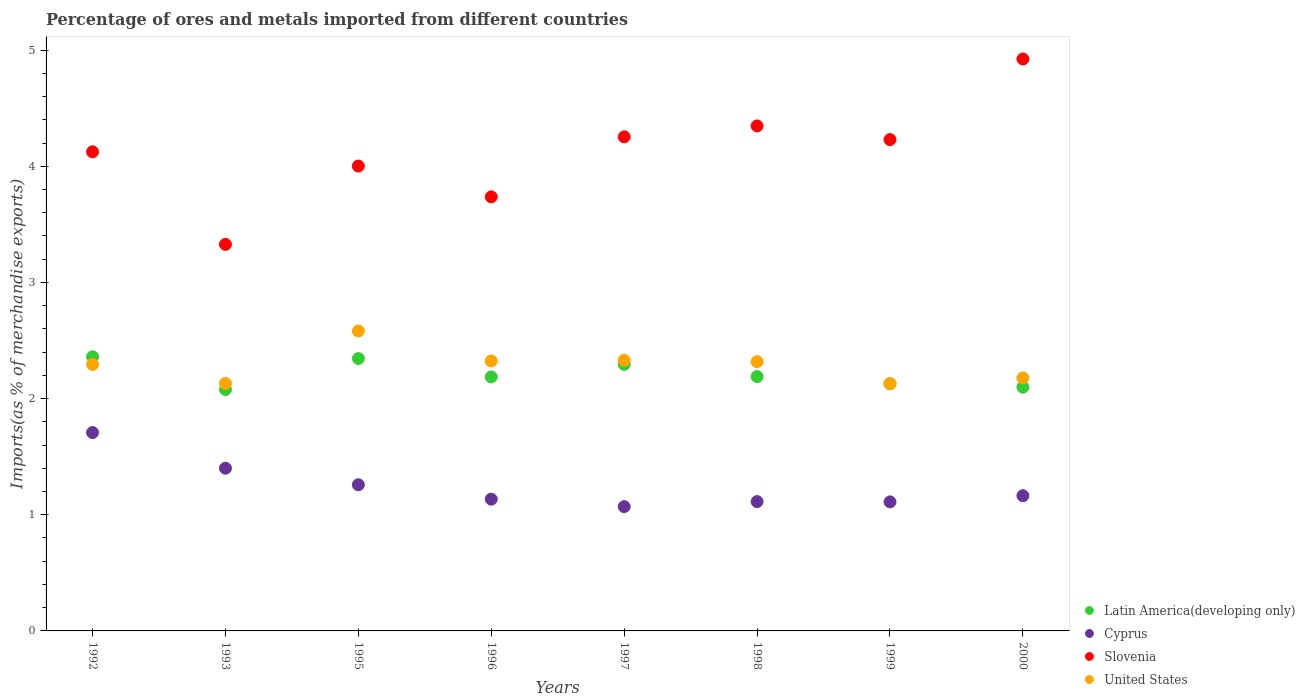How many different coloured dotlines are there?
Provide a short and direct response. 4. Is the number of dotlines equal to the number of legend labels?
Give a very brief answer. Yes. What is the percentage of imports to different countries in Slovenia in 1997?
Ensure brevity in your answer.  4.25. Across all years, what is the maximum percentage of imports to different countries in Latin America(developing only)?
Offer a terse response. 2.36. Across all years, what is the minimum percentage of imports to different countries in Slovenia?
Ensure brevity in your answer.  3.33. What is the total percentage of imports to different countries in United States in the graph?
Provide a succinct answer. 18.28. What is the difference between the percentage of imports to different countries in United States in 1992 and that in 1998?
Ensure brevity in your answer.  -0.02. What is the difference between the percentage of imports to different countries in United States in 2000 and the percentage of imports to different countries in Cyprus in 1996?
Your answer should be compact. 1.04. What is the average percentage of imports to different countries in United States per year?
Offer a terse response. 2.29. In the year 1996, what is the difference between the percentage of imports to different countries in Cyprus and percentage of imports to different countries in Latin America(developing only)?
Provide a succinct answer. -1.05. In how many years, is the percentage of imports to different countries in Latin America(developing only) greater than 1.2 %?
Give a very brief answer. 8. What is the ratio of the percentage of imports to different countries in United States in 1993 to that in 1995?
Ensure brevity in your answer.  0.83. Is the percentage of imports to different countries in Latin America(developing only) in 1996 less than that in 1997?
Provide a succinct answer. Yes. What is the difference between the highest and the second highest percentage of imports to different countries in Slovenia?
Offer a terse response. 0.58. What is the difference between the highest and the lowest percentage of imports to different countries in Latin America(developing only)?
Your answer should be compact. 0.28. In how many years, is the percentage of imports to different countries in Latin America(developing only) greater than the average percentage of imports to different countries in Latin America(developing only) taken over all years?
Offer a very short reply. 3. Does the percentage of imports to different countries in United States monotonically increase over the years?
Provide a succinct answer. No. Is the percentage of imports to different countries in Slovenia strictly less than the percentage of imports to different countries in United States over the years?
Make the answer very short. No. Does the graph contain grids?
Provide a short and direct response. No. Where does the legend appear in the graph?
Your answer should be compact. Bottom right. What is the title of the graph?
Make the answer very short. Percentage of ores and metals imported from different countries. What is the label or title of the X-axis?
Keep it short and to the point. Years. What is the label or title of the Y-axis?
Offer a very short reply. Imports(as % of merchandise exports). What is the Imports(as % of merchandise exports) in Latin America(developing only) in 1992?
Provide a succinct answer. 2.36. What is the Imports(as % of merchandise exports) of Cyprus in 1992?
Provide a succinct answer. 1.71. What is the Imports(as % of merchandise exports) in Slovenia in 1992?
Provide a succinct answer. 4.12. What is the Imports(as % of merchandise exports) in United States in 1992?
Give a very brief answer. 2.29. What is the Imports(as % of merchandise exports) in Latin America(developing only) in 1993?
Your answer should be compact. 2.08. What is the Imports(as % of merchandise exports) of Cyprus in 1993?
Provide a succinct answer. 1.4. What is the Imports(as % of merchandise exports) in Slovenia in 1993?
Provide a succinct answer. 3.33. What is the Imports(as % of merchandise exports) of United States in 1993?
Your answer should be very brief. 2.13. What is the Imports(as % of merchandise exports) of Latin America(developing only) in 1995?
Provide a short and direct response. 2.34. What is the Imports(as % of merchandise exports) of Cyprus in 1995?
Ensure brevity in your answer.  1.26. What is the Imports(as % of merchandise exports) of Slovenia in 1995?
Offer a very short reply. 4. What is the Imports(as % of merchandise exports) in United States in 1995?
Your response must be concise. 2.58. What is the Imports(as % of merchandise exports) of Latin America(developing only) in 1996?
Provide a succinct answer. 2.19. What is the Imports(as % of merchandise exports) of Cyprus in 1996?
Ensure brevity in your answer.  1.13. What is the Imports(as % of merchandise exports) of Slovenia in 1996?
Provide a short and direct response. 3.74. What is the Imports(as % of merchandise exports) in United States in 1996?
Offer a terse response. 2.32. What is the Imports(as % of merchandise exports) in Latin America(developing only) in 1997?
Provide a short and direct response. 2.29. What is the Imports(as % of merchandise exports) in Cyprus in 1997?
Your answer should be very brief. 1.07. What is the Imports(as % of merchandise exports) in Slovenia in 1997?
Your answer should be very brief. 4.25. What is the Imports(as % of merchandise exports) of United States in 1997?
Keep it short and to the point. 2.33. What is the Imports(as % of merchandise exports) of Latin America(developing only) in 1998?
Your response must be concise. 2.19. What is the Imports(as % of merchandise exports) of Cyprus in 1998?
Provide a succinct answer. 1.11. What is the Imports(as % of merchandise exports) in Slovenia in 1998?
Offer a very short reply. 4.35. What is the Imports(as % of merchandise exports) in United States in 1998?
Keep it short and to the point. 2.32. What is the Imports(as % of merchandise exports) of Latin America(developing only) in 1999?
Keep it short and to the point. 2.13. What is the Imports(as % of merchandise exports) of Cyprus in 1999?
Your answer should be compact. 1.11. What is the Imports(as % of merchandise exports) in Slovenia in 1999?
Your answer should be compact. 4.23. What is the Imports(as % of merchandise exports) in United States in 1999?
Provide a short and direct response. 2.13. What is the Imports(as % of merchandise exports) in Latin America(developing only) in 2000?
Your answer should be compact. 2.1. What is the Imports(as % of merchandise exports) of Cyprus in 2000?
Your answer should be very brief. 1.16. What is the Imports(as % of merchandise exports) in Slovenia in 2000?
Your answer should be very brief. 4.92. What is the Imports(as % of merchandise exports) of United States in 2000?
Your response must be concise. 2.18. Across all years, what is the maximum Imports(as % of merchandise exports) in Latin America(developing only)?
Offer a very short reply. 2.36. Across all years, what is the maximum Imports(as % of merchandise exports) of Cyprus?
Keep it short and to the point. 1.71. Across all years, what is the maximum Imports(as % of merchandise exports) of Slovenia?
Your answer should be compact. 4.92. Across all years, what is the maximum Imports(as % of merchandise exports) in United States?
Your answer should be very brief. 2.58. Across all years, what is the minimum Imports(as % of merchandise exports) in Latin America(developing only)?
Offer a very short reply. 2.08. Across all years, what is the minimum Imports(as % of merchandise exports) in Cyprus?
Your answer should be very brief. 1.07. Across all years, what is the minimum Imports(as % of merchandise exports) in Slovenia?
Provide a succinct answer. 3.33. Across all years, what is the minimum Imports(as % of merchandise exports) of United States?
Your answer should be very brief. 2.13. What is the total Imports(as % of merchandise exports) of Latin America(developing only) in the graph?
Make the answer very short. 17.68. What is the total Imports(as % of merchandise exports) of Cyprus in the graph?
Ensure brevity in your answer.  9.96. What is the total Imports(as % of merchandise exports) of Slovenia in the graph?
Keep it short and to the point. 32.94. What is the total Imports(as % of merchandise exports) of United States in the graph?
Provide a succinct answer. 18.28. What is the difference between the Imports(as % of merchandise exports) of Latin America(developing only) in 1992 and that in 1993?
Offer a very short reply. 0.28. What is the difference between the Imports(as % of merchandise exports) of Cyprus in 1992 and that in 1993?
Your answer should be compact. 0.31. What is the difference between the Imports(as % of merchandise exports) in Slovenia in 1992 and that in 1993?
Provide a short and direct response. 0.8. What is the difference between the Imports(as % of merchandise exports) of United States in 1992 and that in 1993?
Make the answer very short. 0.16. What is the difference between the Imports(as % of merchandise exports) in Latin America(developing only) in 1992 and that in 1995?
Ensure brevity in your answer.  0.02. What is the difference between the Imports(as % of merchandise exports) of Cyprus in 1992 and that in 1995?
Make the answer very short. 0.45. What is the difference between the Imports(as % of merchandise exports) of Slovenia in 1992 and that in 1995?
Offer a terse response. 0.12. What is the difference between the Imports(as % of merchandise exports) in United States in 1992 and that in 1995?
Offer a terse response. -0.29. What is the difference between the Imports(as % of merchandise exports) in Latin America(developing only) in 1992 and that in 1996?
Make the answer very short. 0.17. What is the difference between the Imports(as % of merchandise exports) in Cyprus in 1992 and that in 1996?
Your response must be concise. 0.57. What is the difference between the Imports(as % of merchandise exports) of Slovenia in 1992 and that in 1996?
Make the answer very short. 0.39. What is the difference between the Imports(as % of merchandise exports) of United States in 1992 and that in 1996?
Your answer should be very brief. -0.03. What is the difference between the Imports(as % of merchandise exports) of Latin America(developing only) in 1992 and that in 1997?
Keep it short and to the point. 0.07. What is the difference between the Imports(as % of merchandise exports) in Cyprus in 1992 and that in 1997?
Make the answer very short. 0.64. What is the difference between the Imports(as % of merchandise exports) of Slovenia in 1992 and that in 1997?
Provide a short and direct response. -0.13. What is the difference between the Imports(as % of merchandise exports) in United States in 1992 and that in 1997?
Your answer should be compact. -0.04. What is the difference between the Imports(as % of merchandise exports) in Latin America(developing only) in 1992 and that in 1998?
Ensure brevity in your answer.  0.17. What is the difference between the Imports(as % of merchandise exports) of Cyprus in 1992 and that in 1998?
Your response must be concise. 0.59. What is the difference between the Imports(as % of merchandise exports) of Slovenia in 1992 and that in 1998?
Provide a succinct answer. -0.22. What is the difference between the Imports(as % of merchandise exports) in United States in 1992 and that in 1998?
Ensure brevity in your answer.  -0.02. What is the difference between the Imports(as % of merchandise exports) in Latin America(developing only) in 1992 and that in 1999?
Offer a terse response. 0.23. What is the difference between the Imports(as % of merchandise exports) of Cyprus in 1992 and that in 1999?
Provide a short and direct response. 0.6. What is the difference between the Imports(as % of merchandise exports) in Slovenia in 1992 and that in 1999?
Your response must be concise. -0.11. What is the difference between the Imports(as % of merchandise exports) in United States in 1992 and that in 1999?
Keep it short and to the point. 0.16. What is the difference between the Imports(as % of merchandise exports) of Latin America(developing only) in 1992 and that in 2000?
Provide a succinct answer. 0.26. What is the difference between the Imports(as % of merchandise exports) in Cyprus in 1992 and that in 2000?
Your answer should be compact. 0.54. What is the difference between the Imports(as % of merchandise exports) in Slovenia in 1992 and that in 2000?
Ensure brevity in your answer.  -0.8. What is the difference between the Imports(as % of merchandise exports) in United States in 1992 and that in 2000?
Offer a terse response. 0.12. What is the difference between the Imports(as % of merchandise exports) in Latin America(developing only) in 1993 and that in 1995?
Make the answer very short. -0.27. What is the difference between the Imports(as % of merchandise exports) of Cyprus in 1993 and that in 1995?
Your answer should be very brief. 0.14. What is the difference between the Imports(as % of merchandise exports) in Slovenia in 1993 and that in 1995?
Offer a terse response. -0.67. What is the difference between the Imports(as % of merchandise exports) of United States in 1993 and that in 1995?
Your answer should be very brief. -0.45. What is the difference between the Imports(as % of merchandise exports) of Latin America(developing only) in 1993 and that in 1996?
Keep it short and to the point. -0.11. What is the difference between the Imports(as % of merchandise exports) in Cyprus in 1993 and that in 1996?
Your response must be concise. 0.27. What is the difference between the Imports(as % of merchandise exports) in Slovenia in 1993 and that in 1996?
Keep it short and to the point. -0.41. What is the difference between the Imports(as % of merchandise exports) in United States in 1993 and that in 1996?
Offer a terse response. -0.19. What is the difference between the Imports(as % of merchandise exports) of Latin America(developing only) in 1993 and that in 1997?
Offer a very short reply. -0.22. What is the difference between the Imports(as % of merchandise exports) of Cyprus in 1993 and that in 1997?
Your answer should be compact. 0.33. What is the difference between the Imports(as % of merchandise exports) in Slovenia in 1993 and that in 1997?
Your response must be concise. -0.93. What is the difference between the Imports(as % of merchandise exports) of United States in 1993 and that in 1997?
Your answer should be compact. -0.2. What is the difference between the Imports(as % of merchandise exports) in Latin America(developing only) in 1993 and that in 1998?
Offer a terse response. -0.11. What is the difference between the Imports(as % of merchandise exports) of Cyprus in 1993 and that in 1998?
Keep it short and to the point. 0.29. What is the difference between the Imports(as % of merchandise exports) in Slovenia in 1993 and that in 1998?
Offer a very short reply. -1.02. What is the difference between the Imports(as % of merchandise exports) of United States in 1993 and that in 1998?
Offer a very short reply. -0.19. What is the difference between the Imports(as % of merchandise exports) of Latin America(developing only) in 1993 and that in 1999?
Offer a terse response. -0.05. What is the difference between the Imports(as % of merchandise exports) of Cyprus in 1993 and that in 1999?
Your answer should be compact. 0.29. What is the difference between the Imports(as % of merchandise exports) in Slovenia in 1993 and that in 1999?
Provide a short and direct response. -0.9. What is the difference between the Imports(as % of merchandise exports) of United States in 1993 and that in 1999?
Provide a short and direct response. 0. What is the difference between the Imports(as % of merchandise exports) of Latin America(developing only) in 1993 and that in 2000?
Make the answer very short. -0.02. What is the difference between the Imports(as % of merchandise exports) in Cyprus in 1993 and that in 2000?
Give a very brief answer. 0.24. What is the difference between the Imports(as % of merchandise exports) of Slovenia in 1993 and that in 2000?
Keep it short and to the point. -1.6. What is the difference between the Imports(as % of merchandise exports) of United States in 1993 and that in 2000?
Keep it short and to the point. -0.05. What is the difference between the Imports(as % of merchandise exports) in Latin America(developing only) in 1995 and that in 1996?
Provide a succinct answer. 0.16. What is the difference between the Imports(as % of merchandise exports) in Cyprus in 1995 and that in 1996?
Your response must be concise. 0.12. What is the difference between the Imports(as % of merchandise exports) in Slovenia in 1995 and that in 1996?
Provide a succinct answer. 0.27. What is the difference between the Imports(as % of merchandise exports) of United States in 1995 and that in 1996?
Make the answer very short. 0.26. What is the difference between the Imports(as % of merchandise exports) of Latin America(developing only) in 1995 and that in 1997?
Give a very brief answer. 0.05. What is the difference between the Imports(as % of merchandise exports) in Cyprus in 1995 and that in 1997?
Make the answer very short. 0.19. What is the difference between the Imports(as % of merchandise exports) of Slovenia in 1995 and that in 1997?
Your response must be concise. -0.25. What is the difference between the Imports(as % of merchandise exports) in United States in 1995 and that in 1997?
Offer a terse response. 0.25. What is the difference between the Imports(as % of merchandise exports) of Latin America(developing only) in 1995 and that in 1998?
Give a very brief answer. 0.16. What is the difference between the Imports(as % of merchandise exports) of Cyprus in 1995 and that in 1998?
Your response must be concise. 0.14. What is the difference between the Imports(as % of merchandise exports) of Slovenia in 1995 and that in 1998?
Provide a succinct answer. -0.35. What is the difference between the Imports(as % of merchandise exports) in United States in 1995 and that in 1998?
Give a very brief answer. 0.26. What is the difference between the Imports(as % of merchandise exports) of Latin America(developing only) in 1995 and that in 1999?
Offer a very short reply. 0.22. What is the difference between the Imports(as % of merchandise exports) of Cyprus in 1995 and that in 1999?
Ensure brevity in your answer.  0.15. What is the difference between the Imports(as % of merchandise exports) of Slovenia in 1995 and that in 1999?
Your answer should be very brief. -0.23. What is the difference between the Imports(as % of merchandise exports) of United States in 1995 and that in 1999?
Your response must be concise. 0.45. What is the difference between the Imports(as % of merchandise exports) of Latin America(developing only) in 1995 and that in 2000?
Offer a very short reply. 0.25. What is the difference between the Imports(as % of merchandise exports) of Cyprus in 1995 and that in 2000?
Your answer should be very brief. 0.09. What is the difference between the Imports(as % of merchandise exports) in Slovenia in 1995 and that in 2000?
Ensure brevity in your answer.  -0.92. What is the difference between the Imports(as % of merchandise exports) of United States in 1995 and that in 2000?
Offer a very short reply. 0.4. What is the difference between the Imports(as % of merchandise exports) of Latin America(developing only) in 1996 and that in 1997?
Your answer should be compact. -0.11. What is the difference between the Imports(as % of merchandise exports) in Cyprus in 1996 and that in 1997?
Your answer should be compact. 0.06. What is the difference between the Imports(as % of merchandise exports) of Slovenia in 1996 and that in 1997?
Your response must be concise. -0.52. What is the difference between the Imports(as % of merchandise exports) of United States in 1996 and that in 1997?
Your response must be concise. -0.01. What is the difference between the Imports(as % of merchandise exports) in Latin America(developing only) in 1996 and that in 1998?
Give a very brief answer. -0. What is the difference between the Imports(as % of merchandise exports) in Cyprus in 1996 and that in 1998?
Keep it short and to the point. 0.02. What is the difference between the Imports(as % of merchandise exports) in Slovenia in 1996 and that in 1998?
Offer a terse response. -0.61. What is the difference between the Imports(as % of merchandise exports) in United States in 1996 and that in 1998?
Offer a very short reply. 0.01. What is the difference between the Imports(as % of merchandise exports) of Latin America(developing only) in 1996 and that in 1999?
Ensure brevity in your answer.  0.06. What is the difference between the Imports(as % of merchandise exports) in Cyprus in 1996 and that in 1999?
Make the answer very short. 0.02. What is the difference between the Imports(as % of merchandise exports) in Slovenia in 1996 and that in 1999?
Provide a succinct answer. -0.49. What is the difference between the Imports(as % of merchandise exports) of United States in 1996 and that in 1999?
Provide a short and direct response. 0.19. What is the difference between the Imports(as % of merchandise exports) in Latin America(developing only) in 1996 and that in 2000?
Give a very brief answer. 0.09. What is the difference between the Imports(as % of merchandise exports) in Cyprus in 1996 and that in 2000?
Provide a short and direct response. -0.03. What is the difference between the Imports(as % of merchandise exports) in Slovenia in 1996 and that in 2000?
Give a very brief answer. -1.19. What is the difference between the Imports(as % of merchandise exports) in United States in 1996 and that in 2000?
Your answer should be very brief. 0.15. What is the difference between the Imports(as % of merchandise exports) of Latin America(developing only) in 1997 and that in 1998?
Keep it short and to the point. 0.1. What is the difference between the Imports(as % of merchandise exports) of Cyprus in 1997 and that in 1998?
Your answer should be very brief. -0.04. What is the difference between the Imports(as % of merchandise exports) of Slovenia in 1997 and that in 1998?
Provide a short and direct response. -0.09. What is the difference between the Imports(as % of merchandise exports) in United States in 1997 and that in 1998?
Keep it short and to the point. 0.01. What is the difference between the Imports(as % of merchandise exports) in Latin America(developing only) in 1997 and that in 1999?
Your answer should be very brief. 0.17. What is the difference between the Imports(as % of merchandise exports) in Cyprus in 1997 and that in 1999?
Provide a short and direct response. -0.04. What is the difference between the Imports(as % of merchandise exports) of Slovenia in 1997 and that in 1999?
Keep it short and to the point. 0.02. What is the difference between the Imports(as % of merchandise exports) of United States in 1997 and that in 1999?
Provide a short and direct response. 0.2. What is the difference between the Imports(as % of merchandise exports) in Latin America(developing only) in 1997 and that in 2000?
Your answer should be very brief. 0.2. What is the difference between the Imports(as % of merchandise exports) in Cyprus in 1997 and that in 2000?
Make the answer very short. -0.09. What is the difference between the Imports(as % of merchandise exports) in Slovenia in 1997 and that in 2000?
Your answer should be compact. -0.67. What is the difference between the Imports(as % of merchandise exports) of United States in 1997 and that in 2000?
Your answer should be very brief. 0.15. What is the difference between the Imports(as % of merchandise exports) in Latin America(developing only) in 1998 and that in 1999?
Make the answer very short. 0.06. What is the difference between the Imports(as % of merchandise exports) in Cyprus in 1998 and that in 1999?
Provide a succinct answer. 0. What is the difference between the Imports(as % of merchandise exports) of Slovenia in 1998 and that in 1999?
Your response must be concise. 0.12. What is the difference between the Imports(as % of merchandise exports) of United States in 1998 and that in 1999?
Your response must be concise. 0.19. What is the difference between the Imports(as % of merchandise exports) in Latin America(developing only) in 1998 and that in 2000?
Offer a very short reply. 0.09. What is the difference between the Imports(as % of merchandise exports) in Cyprus in 1998 and that in 2000?
Your answer should be very brief. -0.05. What is the difference between the Imports(as % of merchandise exports) in Slovenia in 1998 and that in 2000?
Your response must be concise. -0.58. What is the difference between the Imports(as % of merchandise exports) of United States in 1998 and that in 2000?
Provide a short and direct response. 0.14. What is the difference between the Imports(as % of merchandise exports) of Latin America(developing only) in 1999 and that in 2000?
Give a very brief answer. 0.03. What is the difference between the Imports(as % of merchandise exports) in Cyprus in 1999 and that in 2000?
Make the answer very short. -0.05. What is the difference between the Imports(as % of merchandise exports) in Slovenia in 1999 and that in 2000?
Make the answer very short. -0.69. What is the difference between the Imports(as % of merchandise exports) of United States in 1999 and that in 2000?
Your answer should be very brief. -0.05. What is the difference between the Imports(as % of merchandise exports) in Latin America(developing only) in 1992 and the Imports(as % of merchandise exports) in Cyprus in 1993?
Provide a succinct answer. 0.96. What is the difference between the Imports(as % of merchandise exports) of Latin America(developing only) in 1992 and the Imports(as % of merchandise exports) of Slovenia in 1993?
Your response must be concise. -0.97. What is the difference between the Imports(as % of merchandise exports) in Latin America(developing only) in 1992 and the Imports(as % of merchandise exports) in United States in 1993?
Your response must be concise. 0.23. What is the difference between the Imports(as % of merchandise exports) in Cyprus in 1992 and the Imports(as % of merchandise exports) in Slovenia in 1993?
Offer a terse response. -1.62. What is the difference between the Imports(as % of merchandise exports) of Cyprus in 1992 and the Imports(as % of merchandise exports) of United States in 1993?
Your answer should be very brief. -0.42. What is the difference between the Imports(as % of merchandise exports) in Slovenia in 1992 and the Imports(as % of merchandise exports) in United States in 1993?
Your response must be concise. 1.99. What is the difference between the Imports(as % of merchandise exports) in Latin America(developing only) in 1992 and the Imports(as % of merchandise exports) in Cyprus in 1995?
Offer a very short reply. 1.1. What is the difference between the Imports(as % of merchandise exports) of Latin America(developing only) in 1992 and the Imports(as % of merchandise exports) of Slovenia in 1995?
Ensure brevity in your answer.  -1.64. What is the difference between the Imports(as % of merchandise exports) in Latin America(developing only) in 1992 and the Imports(as % of merchandise exports) in United States in 1995?
Keep it short and to the point. -0.22. What is the difference between the Imports(as % of merchandise exports) in Cyprus in 1992 and the Imports(as % of merchandise exports) in Slovenia in 1995?
Provide a short and direct response. -2.29. What is the difference between the Imports(as % of merchandise exports) in Cyprus in 1992 and the Imports(as % of merchandise exports) in United States in 1995?
Your answer should be very brief. -0.87. What is the difference between the Imports(as % of merchandise exports) of Slovenia in 1992 and the Imports(as % of merchandise exports) of United States in 1995?
Keep it short and to the point. 1.54. What is the difference between the Imports(as % of merchandise exports) of Latin America(developing only) in 1992 and the Imports(as % of merchandise exports) of Cyprus in 1996?
Offer a very short reply. 1.23. What is the difference between the Imports(as % of merchandise exports) of Latin America(developing only) in 1992 and the Imports(as % of merchandise exports) of Slovenia in 1996?
Your answer should be compact. -1.38. What is the difference between the Imports(as % of merchandise exports) of Latin America(developing only) in 1992 and the Imports(as % of merchandise exports) of United States in 1996?
Provide a short and direct response. 0.04. What is the difference between the Imports(as % of merchandise exports) of Cyprus in 1992 and the Imports(as % of merchandise exports) of Slovenia in 1996?
Your answer should be compact. -2.03. What is the difference between the Imports(as % of merchandise exports) in Cyprus in 1992 and the Imports(as % of merchandise exports) in United States in 1996?
Your response must be concise. -0.62. What is the difference between the Imports(as % of merchandise exports) of Slovenia in 1992 and the Imports(as % of merchandise exports) of United States in 1996?
Your answer should be compact. 1.8. What is the difference between the Imports(as % of merchandise exports) in Latin America(developing only) in 1992 and the Imports(as % of merchandise exports) in Cyprus in 1997?
Offer a very short reply. 1.29. What is the difference between the Imports(as % of merchandise exports) in Latin America(developing only) in 1992 and the Imports(as % of merchandise exports) in Slovenia in 1997?
Provide a succinct answer. -1.89. What is the difference between the Imports(as % of merchandise exports) in Latin America(developing only) in 1992 and the Imports(as % of merchandise exports) in United States in 1997?
Keep it short and to the point. 0.03. What is the difference between the Imports(as % of merchandise exports) of Cyprus in 1992 and the Imports(as % of merchandise exports) of Slovenia in 1997?
Your answer should be very brief. -2.55. What is the difference between the Imports(as % of merchandise exports) of Cyprus in 1992 and the Imports(as % of merchandise exports) of United States in 1997?
Offer a terse response. -0.62. What is the difference between the Imports(as % of merchandise exports) in Slovenia in 1992 and the Imports(as % of merchandise exports) in United States in 1997?
Provide a succinct answer. 1.79. What is the difference between the Imports(as % of merchandise exports) in Latin America(developing only) in 1992 and the Imports(as % of merchandise exports) in Cyprus in 1998?
Ensure brevity in your answer.  1.25. What is the difference between the Imports(as % of merchandise exports) in Latin America(developing only) in 1992 and the Imports(as % of merchandise exports) in Slovenia in 1998?
Offer a terse response. -1.99. What is the difference between the Imports(as % of merchandise exports) of Latin America(developing only) in 1992 and the Imports(as % of merchandise exports) of United States in 1998?
Your response must be concise. 0.04. What is the difference between the Imports(as % of merchandise exports) of Cyprus in 1992 and the Imports(as % of merchandise exports) of Slovenia in 1998?
Ensure brevity in your answer.  -2.64. What is the difference between the Imports(as % of merchandise exports) in Cyprus in 1992 and the Imports(as % of merchandise exports) in United States in 1998?
Offer a terse response. -0.61. What is the difference between the Imports(as % of merchandise exports) of Slovenia in 1992 and the Imports(as % of merchandise exports) of United States in 1998?
Offer a very short reply. 1.81. What is the difference between the Imports(as % of merchandise exports) of Latin America(developing only) in 1992 and the Imports(as % of merchandise exports) of Cyprus in 1999?
Offer a very short reply. 1.25. What is the difference between the Imports(as % of merchandise exports) of Latin America(developing only) in 1992 and the Imports(as % of merchandise exports) of Slovenia in 1999?
Give a very brief answer. -1.87. What is the difference between the Imports(as % of merchandise exports) in Latin America(developing only) in 1992 and the Imports(as % of merchandise exports) in United States in 1999?
Keep it short and to the point. 0.23. What is the difference between the Imports(as % of merchandise exports) of Cyprus in 1992 and the Imports(as % of merchandise exports) of Slovenia in 1999?
Provide a short and direct response. -2.52. What is the difference between the Imports(as % of merchandise exports) in Cyprus in 1992 and the Imports(as % of merchandise exports) in United States in 1999?
Ensure brevity in your answer.  -0.42. What is the difference between the Imports(as % of merchandise exports) in Slovenia in 1992 and the Imports(as % of merchandise exports) in United States in 1999?
Offer a very short reply. 2. What is the difference between the Imports(as % of merchandise exports) of Latin America(developing only) in 1992 and the Imports(as % of merchandise exports) of Cyprus in 2000?
Your answer should be compact. 1.2. What is the difference between the Imports(as % of merchandise exports) of Latin America(developing only) in 1992 and the Imports(as % of merchandise exports) of Slovenia in 2000?
Your response must be concise. -2.56. What is the difference between the Imports(as % of merchandise exports) in Latin America(developing only) in 1992 and the Imports(as % of merchandise exports) in United States in 2000?
Provide a short and direct response. 0.18. What is the difference between the Imports(as % of merchandise exports) of Cyprus in 1992 and the Imports(as % of merchandise exports) of Slovenia in 2000?
Make the answer very short. -3.22. What is the difference between the Imports(as % of merchandise exports) of Cyprus in 1992 and the Imports(as % of merchandise exports) of United States in 2000?
Offer a terse response. -0.47. What is the difference between the Imports(as % of merchandise exports) in Slovenia in 1992 and the Imports(as % of merchandise exports) in United States in 2000?
Provide a short and direct response. 1.95. What is the difference between the Imports(as % of merchandise exports) of Latin America(developing only) in 1993 and the Imports(as % of merchandise exports) of Cyprus in 1995?
Keep it short and to the point. 0.82. What is the difference between the Imports(as % of merchandise exports) of Latin America(developing only) in 1993 and the Imports(as % of merchandise exports) of Slovenia in 1995?
Keep it short and to the point. -1.92. What is the difference between the Imports(as % of merchandise exports) in Latin America(developing only) in 1993 and the Imports(as % of merchandise exports) in United States in 1995?
Make the answer very short. -0.5. What is the difference between the Imports(as % of merchandise exports) of Cyprus in 1993 and the Imports(as % of merchandise exports) of Slovenia in 1995?
Your answer should be very brief. -2.6. What is the difference between the Imports(as % of merchandise exports) in Cyprus in 1993 and the Imports(as % of merchandise exports) in United States in 1995?
Make the answer very short. -1.18. What is the difference between the Imports(as % of merchandise exports) of Slovenia in 1993 and the Imports(as % of merchandise exports) of United States in 1995?
Your response must be concise. 0.75. What is the difference between the Imports(as % of merchandise exports) in Latin America(developing only) in 1993 and the Imports(as % of merchandise exports) in Cyprus in 1996?
Make the answer very short. 0.94. What is the difference between the Imports(as % of merchandise exports) in Latin America(developing only) in 1993 and the Imports(as % of merchandise exports) in Slovenia in 1996?
Make the answer very short. -1.66. What is the difference between the Imports(as % of merchandise exports) of Latin America(developing only) in 1993 and the Imports(as % of merchandise exports) of United States in 1996?
Keep it short and to the point. -0.25. What is the difference between the Imports(as % of merchandise exports) of Cyprus in 1993 and the Imports(as % of merchandise exports) of Slovenia in 1996?
Offer a very short reply. -2.34. What is the difference between the Imports(as % of merchandise exports) in Cyprus in 1993 and the Imports(as % of merchandise exports) in United States in 1996?
Offer a very short reply. -0.92. What is the difference between the Imports(as % of merchandise exports) of Latin America(developing only) in 1993 and the Imports(as % of merchandise exports) of Cyprus in 1997?
Offer a very short reply. 1.01. What is the difference between the Imports(as % of merchandise exports) in Latin America(developing only) in 1993 and the Imports(as % of merchandise exports) in Slovenia in 1997?
Ensure brevity in your answer.  -2.18. What is the difference between the Imports(as % of merchandise exports) in Latin America(developing only) in 1993 and the Imports(as % of merchandise exports) in United States in 1997?
Provide a short and direct response. -0.25. What is the difference between the Imports(as % of merchandise exports) of Cyprus in 1993 and the Imports(as % of merchandise exports) of Slovenia in 1997?
Offer a very short reply. -2.85. What is the difference between the Imports(as % of merchandise exports) of Cyprus in 1993 and the Imports(as % of merchandise exports) of United States in 1997?
Ensure brevity in your answer.  -0.93. What is the difference between the Imports(as % of merchandise exports) in Slovenia in 1993 and the Imports(as % of merchandise exports) in United States in 1997?
Ensure brevity in your answer.  1. What is the difference between the Imports(as % of merchandise exports) in Latin America(developing only) in 1993 and the Imports(as % of merchandise exports) in Cyprus in 1998?
Your answer should be compact. 0.96. What is the difference between the Imports(as % of merchandise exports) in Latin America(developing only) in 1993 and the Imports(as % of merchandise exports) in Slovenia in 1998?
Keep it short and to the point. -2.27. What is the difference between the Imports(as % of merchandise exports) of Latin America(developing only) in 1993 and the Imports(as % of merchandise exports) of United States in 1998?
Ensure brevity in your answer.  -0.24. What is the difference between the Imports(as % of merchandise exports) in Cyprus in 1993 and the Imports(as % of merchandise exports) in Slovenia in 1998?
Offer a terse response. -2.95. What is the difference between the Imports(as % of merchandise exports) of Cyprus in 1993 and the Imports(as % of merchandise exports) of United States in 1998?
Offer a terse response. -0.92. What is the difference between the Imports(as % of merchandise exports) in Slovenia in 1993 and the Imports(as % of merchandise exports) in United States in 1998?
Provide a succinct answer. 1.01. What is the difference between the Imports(as % of merchandise exports) of Latin America(developing only) in 1993 and the Imports(as % of merchandise exports) of Cyprus in 1999?
Provide a short and direct response. 0.97. What is the difference between the Imports(as % of merchandise exports) of Latin America(developing only) in 1993 and the Imports(as % of merchandise exports) of Slovenia in 1999?
Ensure brevity in your answer.  -2.15. What is the difference between the Imports(as % of merchandise exports) in Latin America(developing only) in 1993 and the Imports(as % of merchandise exports) in United States in 1999?
Make the answer very short. -0.05. What is the difference between the Imports(as % of merchandise exports) in Cyprus in 1993 and the Imports(as % of merchandise exports) in Slovenia in 1999?
Offer a very short reply. -2.83. What is the difference between the Imports(as % of merchandise exports) in Cyprus in 1993 and the Imports(as % of merchandise exports) in United States in 1999?
Offer a terse response. -0.73. What is the difference between the Imports(as % of merchandise exports) in Slovenia in 1993 and the Imports(as % of merchandise exports) in United States in 1999?
Offer a terse response. 1.2. What is the difference between the Imports(as % of merchandise exports) in Latin America(developing only) in 1993 and the Imports(as % of merchandise exports) in Cyprus in 2000?
Provide a short and direct response. 0.91. What is the difference between the Imports(as % of merchandise exports) of Latin America(developing only) in 1993 and the Imports(as % of merchandise exports) of Slovenia in 2000?
Your answer should be compact. -2.85. What is the difference between the Imports(as % of merchandise exports) in Latin America(developing only) in 1993 and the Imports(as % of merchandise exports) in United States in 2000?
Provide a short and direct response. -0.1. What is the difference between the Imports(as % of merchandise exports) of Cyprus in 1993 and the Imports(as % of merchandise exports) of Slovenia in 2000?
Offer a very short reply. -3.52. What is the difference between the Imports(as % of merchandise exports) of Cyprus in 1993 and the Imports(as % of merchandise exports) of United States in 2000?
Offer a terse response. -0.78. What is the difference between the Imports(as % of merchandise exports) of Slovenia in 1993 and the Imports(as % of merchandise exports) of United States in 2000?
Make the answer very short. 1.15. What is the difference between the Imports(as % of merchandise exports) in Latin America(developing only) in 1995 and the Imports(as % of merchandise exports) in Cyprus in 1996?
Offer a very short reply. 1.21. What is the difference between the Imports(as % of merchandise exports) of Latin America(developing only) in 1995 and the Imports(as % of merchandise exports) of Slovenia in 1996?
Make the answer very short. -1.39. What is the difference between the Imports(as % of merchandise exports) of Latin America(developing only) in 1995 and the Imports(as % of merchandise exports) of United States in 1996?
Give a very brief answer. 0.02. What is the difference between the Imports(as % of merchandise exports) in Cyprus in 1995 and the Imports(as % of merchandise exports) in Slovenia in 1996?
Provide a succinct answer. -2.48. What is the difference between the Imports(as % of merchandise exports) in Cyprus in 1995 and the Imports(as % of merchandise exports) in United States in 1996?
Offer a very short reply. -1.07. What is the difference between the Imports(as % of merchandise exports) in Slovenia in 1995 and the Imports(as % of merchandise exports) in United States in 1996?
Make the answer very short. 1.68. What is the difference between the Imports(as % of merchandise exports) of Latin America(developing only) in 1995 and the Imports(as % of merchandise exports) of Cyprus in 1997?
Your response must be concise. 1.27. What is the difference between the Imports(as % of merchandise exports) in Latin America(developing only) in 1995 and the Imports(as % of merchandise exports) in Slovenia in 1997?
Offer a very short reply. -1.91. What is the difference between the Imports(as % of merchandise exports) in Latin America(developing only) in 1995 and the Imports(as % of merchandise exports) in United States in 1997?
Your response must be concise. 0.01. What is the difference between the Imports(as % of merchandise exports) in Cyprus in 1995 and the Imports(as % of merchandise exports) in Slovenia in 1997?
Offer a very short reply. -2.99. What is the difference between the Imports(as % of merchandise exports) of Cyprus in 1995 and the Imports(as % of merchandise exports) of United States in 1997?
Keep it short and to the point. -1.07. What is the difference between the Imports(as % of merchandise exports) of Slovenia in 1995 and the Imports(as % of merchandise exports) of United States in 1997?
Keep it short and to the point. 1.67. What is the difference between the Imports(as % of merchandise exports) of Latin America(developing only) in 1995 and the Imports(as % of merchandise exports) of Cyprus in 1998?
Give a very brief answer. 1.23. What is the difference between the Imports(as % of merchandise exports) of Latin America(developing only) in 1995 and the Imports(as % of merchandise exports) of Slovenia in 1998?
Give a very brief answer. -2. What is the difference between the Imports(as % of merchandise exports) of Latin America(developing only) in 1995 and the Imports(as % of merchandise exports) of United States in 1998?
Provide a short and direct response. 0.03. What is the difference between the Imports(as % of merchandise exports) in Cyprus in 1995 and the Imports(as % of merchandise exports) in Slovenia in 1998?
Your response must be concise. -3.09. What is the difference between the Imports(as % of merchandise exports) of Cyprus in 1995 and the Imports(as % of merchandise exports) of United States in 1998?
Your answer should be very brief. -1.06. What is the difference between the Imports(as % of merchandise exports) of Slovenia in 1995 and the Imports(as % of merchandise exports) of United States in 1998?
Provide a succinct answer. 1.68. What is the difference between the Imports(as % of merchandise exports) of Latin America(developing only) in 1995 and the Imports(as % of merchandise exports) of Cyprus in 1999?
Offer a very short reply. 1.23. What is the difference between the Imports(as % of merchandise exports) in Latin America(developing only) in 1995 and the Imports(as % of merchandise exports) in Slovenia in 1999?
Provide a short and direct response. -1.88. What is the difference between the Imports(as % of merchandise exports) of Latin America(developing only) in 1995 and the Imports(as % of merchandise exports) of United States in 1999?
Keep it short and to the point. 0.22. What is the difference between the Imports(as % of merchandise exports) of Cyprus in 1995 and the Imports(as % of merchandise exports) of Slovenia in 1999?
Your response must be concise. -2.97. What is the difference between the Imports(as % of merchandise exports) in Cyprus in 1995 and the Imports(as % of merchandise exports) in United States in 1999?
Provide a short and direct response. -0.87. What is the difference between the Imports(as % of merchandise exports) of Slovenia in 1995 and the Imports(as % of merchandise exports) of United States in 1999?
Your answer should be compact. 1.87. What is the difference between the Imports(as % of merchandise exports) of Latin America(developing only) in 1995 and the Imports(as % of merchandise exports) of Cyprus in 2000?
Your response must be concise. 1.18. What is the difference between the Imports(as % of merchandise exports) of Latin America(developing only) in 1995 and the Imports(as % of merchandise exports) of Slovenia in 2000?
Ensure brevity in your answer.  -2.58. What is the difference between the Imports(as % of merchandise exports) in Latin America(developing only) in 1995 and the Imports(as % of merchandise exports) in United States in 2000?
Your answer should be compact. 0.17. What is the difference between the Imports(as % of merchandise exports) in Cyprus in 1995 and the Imports(as % of merchandise exports) in Slovenia in 2000?
Keep it short and to the point. -3.67. What is the difference between the Imports(as % of merchandise exports) of Cyprus in 1995 and the Imports(as % of merchandise exports) of United States in 2000?
Make the answer very short. -0.92. What is the difference between the Imports(as % of merchandise exports) of Slovenia in 1995 and the Imports(as % of merchandise exports) of United States in 2000?
Your answer should be compact. 1.82. What is the difference between the Imports(as % of merchandise exports) in Latin America(developing only) in 1996 and the Imports(as % of merchandise exports) in Cyprus in 1997?
Your answer should be compact. 1.12. What is the difference between the Imports(as % of merchandise exports) of Latin America(developing only) in 1996 and the Imports(as % of merchandise exports) of Slovenia in 1997?
Give a very brief answer. -2.07. What is the difference between the Imports(as % of merchandise exports) in Latin America(developing only) in 1996 and the Imports(as % of merchandise exports) in United States in 1997?
Keep it short and to the point. -0.14. What is the difference between the Imports(as % of merchandise exports) in Cyprus in 1996 and the Imports(as % of merchandise exports) in Slovenia in 1997?
Provide a short and direct response. -3.12. What is the difference between the Imports(as % of merchandise exports) of Cyprus in 1996 and the Imports(as % of merchandise exports) of United States in 1997?
Your answer should be very brief. -1.2. What is the difference between the Imports(as % of merchandise exports) of Slovenia in 1996 and the Imports(as % of merchandise exports) of United States in 1997?
Ensure brevity in your answer.  1.41. What is the difference between the Imports(as % of merchandise exports) in Latin America(developing only) in 1996 and the Imports(as % of merchandise exports) in Cyprus in 1998?
Offer a terse response. 1.07. What is the difference between the Imports(as % of merchandise exports) in Latin America(developing only) in 1996 and the Imports(as % of merchandise exports) in Slovenia in 1998?
Your answer should be compact. -2.16. What is the difference between the Imports(as % of merchandise exports) in Latin America(developing only) in 1996 and the Imports(as % of merchandise exports) in United States in 1998?
Offer a terse response. -0.13. What is the difference between the Imports(as % of merchandise exports) of Cyprus in 1996 and the Imports(as % of merchandise exports) of Slovenia in 1998?
Your answer should be very brief. -3.21. What is the difference between the Imports(as % of merchandise exports) in Cyprus in 1996 and the Imports(as % of merchandise exports) in United States in 1998?
Make the answer very short. -1.18. What is the difference between the Imports(as % of merchandise exports) of Slovenia in 1996 and the Imports(as % of merchandise exports) of United States in 1998?
Give a very brief answer. 1.42. What is the difference between the Imports(as % of merchandise exports) in Latin America(developing only) in 1996 and the Imports(as % of merchandise exports) in Cyprus in 1999?
Your answer should be very brief. 1.08. What is the difference between the Imports(as % of merchandise exports) of Latin America(developing only) in 1996 and the Imports(as % of merchandise exports) of Slovenia in 1999?
Offer a very short reply. -2.04. What is the difference between the Imports(as % of merchandise exports) in Latin America(developing only) in 1996 and the Imports(as % of merchandise exports) in United States in 1999?
Provide a short and direct response. 0.06. What is the difference between the Imports(as % of merchandise exports) of Cyprus in 1996 and the Imports(as % of merchandise exports) of Slovenia in 1999?
Keep it short and to the point. -3.1. What is the difference between the Imports(as % of merchandise exports) in Cyprus in 1996 and the Imports(as % of merchandise exports) in United States in 1999?
Your answer should be compact. -0.99. What is the difference between the Imports(as % of merchandise exports) of Slovenia in 1996 and the Imports(as % of merchandise exports) of United States in 1999?
Offer a very short reply. 1.61. What is the difference between the Imports(as % of merchandise exports) of Latin America(developing only) in 1996 and the Imports(as % of merchandise exports) of Cyprus in 2000?
Your response must be concise. 1.02. What is the difference between the Imports(as % of merchandise exports) in Latin America(developing only) in 1996 and the Imports(as % of merchandise exports) in Slovenia in 2000?
Provide a short and direct response. -2.74. What is the difference between the Imports(as % of merchandise exports) of Latin America(developing only) in 1996 and the Imports(as % of merchandise exports) of United States in 2000?
Your answer should be very brief. 0.01. What is the difference between the Imports(as % of merchandise exports) in Cyprus in 1996 and the Imports(as % of merchandise exports) in Slovenia in 2000?
Offer a very short reply. -3.79. What is the difference between the Imports(as % of merchandise exports) in Cyprus in 1996 and the Imports(as % of merchandise exports) in United States in 2000?
Offer a terse response. -1.04. What is the difference between the Imports(as % of merchandise exports) of Slovenia in 1996 and the Imports(as % of merchandise exports) of United States in 2000?
Offer a very short reply. 1.56. What is the difference between the Imports(as % of merchandise exports) of Latin America(developing only) in 1997 and the Imports(as % of merchandise exports) of Cyprus in 1998?
Provide a succinct answer. 1.18. What is the difference between the Imports(as % of merchandise exports) in Latin America(developing only) in 1997 and the Imports(as % of merchandise exports) in Slovenia in 1998?
Your answer should be very brief. -2.05. What is the difference between the Imports(as % of merchandise exports) of Latin America(developing only) in 1997 and the Imports(as % of merchandise exports) of United States in 1998?
Your answer should be very brief. -0.02. What is the difference between the Imports(as % of merchandise exports) in Cyprus in 1997 and the Imports(as % of merchandise exports) in Slovenia in 1998?
Give a very brief answer. -3.28. What is the difference between the Imports(as % of merchandise exports) in Cyprus in 1997 and the Imports(as % of merchandise exports) in United States in 1998?
Offer a very short reply. -1.25. What is the difference between the Imports(as % of merchandise exports) of Slovenia in 1997 and the Imports(as % of merchandise exports) of United States in 1998?
Ensure brevity in your answer.  1.94. What is the difference between the Imports(as % of merchandise exports) in Latin America(developing only) in 1997 and the Imports(as % of merchandise exports) in Cyprus in 1999?
Provide a short and direct response. 1.18. What is the difference between the Imports(as % of merchandise exports) of Latin America(developing only) in 1997 and the Imports(as % of merchandise exports) of Slovenia in 1999?
Provide a short and direct response. -1.94. What is the difference between the Imports(as % of merchandise exports) in Latin America(developing only) in 1997 and the Imports(as % of merchandise exports) in United States in 1999?
Your response must be concise. 0.17. What is the difference between the Imports(as % of merchandise exports) of Cyprus in 1997 and the Imports(as % of merchandise exports) of Slovenia in 1999?
Your response must be concise. -3.16. What is the difference between the Imports(as % of merchandise exports) in Cyprus in 1997 and the Imports(as % of merchandise exports) in United States in 1999?
Offer a very short reply. -1.06. What is the difference between the Imports(as % of merchandise exports) in Slovenia in 1997 and the Imports(as % of merchandise exports) in United States in 1999?
Make the answer very short. 2.12. What is the difference between the Imports(as % of merchandise exports) in Latin America(developing only) in 1997 and the Imports(as % of merchandise exports) in Cyprus in 2000?
Your answer should be very brief. 1.13. What is the difference between the Imports(as % of merchandise exports) of Latin America(developing only) in 1997 and the Imports(as % of merchandise exports) of Slovenia in 2000?
Your answer should be compact. -2.63. What is the difference between the Imports(as % of merchandise exports) in Latin America(developing only) in 1997 and the Imports(as % of merchandise exports) in United States in 2000?
Keep it short and to the point. 0.12. What is the difference between the Imports(as % of merchandise exports) of Cyprus in 1997 and the Imports(as % of merchandise exports) of Slovenia in 2000?
Your answer should be very brief. -3.85. What is the difference between the Imports(as % of merchandise exports) of Cyprus in 1997 and the Imports(as % of merchandise exports) of United States in 2000?
Ensure brevity in your answer.  -1.11. What is the difference between the Imports(as % of merchandise exports) of Slovenia in 1997 and the Imports(as % of merchandise exports) of United States in 2000?
Provide a succinct answer. 2.07. What is the difference between the Imports(as % of merchandise exports) in Latin America(developing only) in 1998 and the Imports(as % of merchandise exports) in Cyprus in 1999?
Offer a very short reply. 1.08. What is the difference between the Imports(as % of merchandise exports) in Latin America(developing only) in 1998 and the Imports(as % of merchandise exports) in Slovenia in 1999?
Offer a terse response. -2.04. What is the difference between the Imports(as % of merchandise exports) of Latin America(developing only) in 1998 and the Imports(as % of merchandise exports) of United States in 1999?
Your answer should be compact. 0.06. What is the difference between the Imports(as % of merchandise exports) in Cyprus in 1998 and the Imports(as % of merchandise exports) in Slovenia in 1999?
Your response must be concise. -3.12. What is the difference between the Imports(as % of merchandise exports) of Cyprus in 1998 and the Imports(as % of merchandise exports) of United States in 1999?
Give a very brief answer. -1.02. What is the difference between the Imports(as % of merchandise exports) of Slovenia in 1998 and the Imports(as % of merchandise exports) of United States in 1999?
Make the answer very short. 2.22. What is the difference between the Imports(as % of merchandise exports) of Latin America(developing only) in 1998 and the Imports(as % of merchandise exports) of Cyprus in 2000?
Keep it short and to the point. 1.03. What is the difference between the Imports(as % of merchandise exports) of Latin America(developing only) in 1998 and the Imports(as % of merchandise exports) of Slovenia in 2000?
Your answer should be very brief. -2.73. What is the difference between the Imports(as % of merchandise exports) in Latin America(developing only) in 1998 and the Imports(as % of merchandise exports) in United States in 2000?
Ensure brevity in your answer.  0.01. What is the difference between the Imports(as % of merchandise exports) in Cyprus in 1998 and the Imports(as % of merchandise exports) in Slovenia in 2000?
Make the answer very short. -3.81. What is the difference between the Imports(as % of merchandise exports) of Cyprus in 1998 and the Imports(as % of merchandise exports) of United States in 2000?
Your answer should be very brief. -1.06. What is the difference between the Imports(as % of merchandise exports) in Slovenia in 1998 and the Imports(as % of merchandise exports) in United States in 2000?
Offer a terse response. 2.17. What is the difference between the Imports(as % of merchandise exports) in Latin America(developing only) in 1999 and the Imports(as % of merchandise exports) in Cyprus in 2000?
Provide a succinct answer. 0.96. What is the difference between the Imports(as % of merchandise exports) in Latin America(developing only) in 1999 and the Imports(as % of merchandise exports) in Slovenia in 2000?
Ensure brevity in your answer.  -2.8. What is the difference between the Imports(as % of merchandise exports) of Latin America(developing only) in 1999 and the Imports(as % of merchandise exports) of United States in 2000?
Your response must be concise. -0.05. What is the difference between the Imports(as % of merchandise exports) of Cyprus in 1999 and the Imports(as % of merchandise exports) of Slovenia in 2000?
Your answer should be very brief. -3.81. What is the difference between the Imports(as % of merchandise exports) of Cyprus in 1999 and the Imports(as % of merchandise exports) of United States in 2000?
Offer a very short reply. -1.07. What is the difference between the Imports(as % of merchandise exports) in Slovenia in 1999 and the Imports(as % of merchandise exports) in United States in 2000?
Provide a succinct answer. 2.05. What is the average Imports(as % of merchandise exports) of Latin America(developing only) per year?
Your response must be concise. 2.21. What is the average Imports(as % of merchandise exports) of Cyprus per year?
Your answer should be very brief. 1.24. What is the average Imports(as % of merchandise exports) of Slovenia per year?
Ensure brevity in your answer.  4.12. What is the average Imports(as % of merchandise exports) in United States per year?
Keep it short and to the point. 2.29. In the year 1992, what is the difference between the Imports(as % of merchandise exports) of Latin America(developing only) and Imports(as % of merchandise exports) of Cyprus?
Provide a succinct answer. 0.65. In the year 1992, what is the difference between the Imports(as % of merchandise exports) in Latin America(developing only) and Imports(as % of merchandise exports) in Slovenia?
Your response must be concise. -1.76. In the year 1992, what is the difference between the Imports(as % of merchandise exports) in Latin America(developing only) and Imports(as % of merchandise exports) in United States?
Your response must be concise. 0.07. In the year 1992, what is the difference between the Imports(as % of merchandise exports) in Cyprus and Imports(as % of merchandise exports) in Slovenia?
Offer a very short reply. -2.42. In the year 1992, what is the difference between the Imports(as % of merchandise exports) in Cyprus and Imports(as % of merchandise exports) in United States?
Keep it short and to the point. -0.59. In the year 1992, what is the difference between the Imports(as % of merchandise exports) in Slovenia and Imports(as % of merchandise exports) in United States?
Provide a short and direct response. 1.83. In the year 1993, what is the difference between the Imports(as % of merchandise exports) in Latin America(developing only) and Imports(as % of merchandise exports) in Cyprus?
Offer a very short reply. 0.68. In the year 1993, what is the difference between the Imports(as % of merchandise exports) in Latin America(developing only) and Imports(as % of merchandise exports) in Slovenia?
Provide a short and direct response. -1.25. In the year 1993, what is the difference between the Imports(as % of merchandise exports) of Latin America(developing only) and Imports(as % of merchandise exports) of United States?
Offer a very short reply. -0.05. In the year 1993, what is the difference between the Imports(as % of merchandise exports) of Cyprus and Imports(as % of merchandise exports) of Slovenia?
Offer a very short reply. -1.93. In the year 1993, what is the difference between the Imports(as % of merchandise exports) of Cyprus and Imports(as % of merchandise exports) of United States?
Your answer should be very brief. -0.73. In the year 1993, what is the difference between the Imports(as % of merchandise exports) of Slovenia and Imports(as % of merchandise exports) of United States?
Offer a terse response. 1.2. In the year 1995, what is the difference between the Imports(as % of merchandise exports) in Latin America(developing only) and Imports(as % of merchandise exports) in Cyprus?
Your response must be concise. 1.09. In the year 1995, what is the difference between the Imports(as % of merchandise exports) of Latin America(developing only) and Imports(as % of merchandise exports) of Slovenia?
Provide a short and direct response. -1.66. In the year 1995, what is the difference between the Imports(as % of merchandise exports) in Latin America(developing only) and Imports(as % of merchandise exports) in United States?
Your answer should be compact. -0.24. In the year 1995, what is the difference between the Imports(as % of merchandise exports) of Cyprus and Imports(as % of merchandise exports) of Slovenia?
Provide a short and direct response. -2.74. In the year 1995, what is the difference between the Imports(as % of merchandise exports) in Cyprus and Imports(as % of merchandise exports) in United States?
Your response must be concise. -1.32. In the year 1995, what is the difference between the Imports(as % of merchandise exports) in Slovenia and Imports(as % of merchandise exports) in United States?
Keep it short and to the point. 1.42. In the year 1996, what is the difference between the Imports(as % of merchandise exports) in Latin America(developing only) and Imports(as % of merchandise exports) in Cyprus?
Your answer should be compact. 1.05. In the year 1996, what is the difference between the Imports(as % of merchandise exports) in Latin America(developing only) and Imports(as % of merchandise exports) in Slovenia?
Keep it short and to the point. -1.55. In the year 1996, what is the difference between the Imports(as % of merchandise exports) of Latin America(developing only) and Imports(as % of merchandise exports) of United States?
Your answer should be very brief. -0.14. In the year 1996, what is the difference between the Imports(as % of merchandise exports) of Cyprus and Imports(as % of merchandise exports) of Slovenia?
Your answer should be very brief. -2.6. In the year 1996, what is the difference between the Imports(as % of merchandise exports) of Cyprus and Imports(as % of merchandise exports) of United States?
Provide a short and direct response. -1.19. In the year 1996, what is the difference between the Imports(as % of merchandise exports) of Slovenia and Imports(as % of merchandise exports) of United States?
Offer a terse response. 1.41. In the year 1997, what is the difference between the Imports(as % of merchandise exports) in Latin America(developing only) and Imports(as % of merchandise exports) in Cyprus?
Your answer should be compact. 1.22. In the year 1997, what is the difference between the Imports(as % of merchandise exports) in Latin America(developing only) and Imports(as % of merchandise exports) in Slovenia?
Offer a very short reply. -1.96. In the year 1997, what is the difference between the Imports(as % of merchandise exports) of Latin America(developing only) and Imports(as % of merchandise exports) of United States?
Provide a succinct answer. -0.04. In the year 1997, what is the difference between the Imports(as % of merchandise exports) of Cyprus and Imports(as % of merchandise exports) of Slovenia?
Make the answer very short. -3.18. In the year 1997, what is the difference between the Imports(as % of merchandise exports) of Cyprus and Imports(as % of merchandise exports) of United States?
Keep it short and to the point. -1.26. In the year 1997, what is the difference between the Imports(as % of merchandise exports) of Slovenia and Imports(as % of merchandise exports) of United States?
Make the answer very short. 1.92. In the year 1998, what is the difference between the Imports(as % of merchandise exports) in Latin America(developing only) and Imports(as % of merchandise exports) in Cyprus?
Your answer should be very brief. 1.08. In the year 1998, what is the difference between the Imports(as % of merchandise exports) of Latin America(developing only) and Imports(as % of merchandise exports) of Slovenia?
Your answer should be very brief. -2.16. In the year 1998, what is the difference between the Imports(as % of merchandise exports) of Latin America(developing only) and Imports(as % of merchandise exports) of United States?
Offer a very short reply. -0.13. In the year 1998, what is the difference between the Imports(as % of merchandise exports) of Cyprus and Imports(as % of merchandise exports) of Slovenia?
Offer a very short reply. -3.23. In the year 1998, what is the difference between the Imports(as % of merchandise exports) of Cyprus and Imports(as % of merchandise exports) of United States?
Offer a terse response. -1.2. In the year 1998, what is the difference between the Imports(as % of merchandise exports) in Slovenia and Imports(as % of merchandise exports) in United States?
Provide a succinct answer. 2.03. In the year 1999, what is the difference between the Imports(as % of merchandise exports) of Latin America(developing only) and Imports(as % of merchandise exports) of Cyprus?
Offer a terse response. 1.02. In the year 1999, what is the difference between the Imports(as % of merchandise exports) in Latin America(developing only) and Imports(as % of merchandise exports) in Slovenia?
Offer a terse response. -2.1. In the year 1999, what is the difference between the Imports(as % of merchandise exports) in Latin America(developing only) and Imports(as % of merchandise exports) in United States?
Provide a short and direct response. -0. In the year 1999, what is the difference between the Imports(as % of merchandise exports) of Cyprus and Imports(as % of merchandise exports) of Slovenia?
Your answer should be compact. -3.12. In the year 1999, what is the difference between the Imports(as % of merchandise exports) in Cyprus and Imports(as % of merchandise exports) in United States?
Give a very brief answer. -1.02. In the year 1999, what is the difference between the Imports(as % of merchandise exports) of Slovenia and Imports(as % of merchandise exports) of United States?
Offer a very short reply. 2.1. In the year 2000, what is the difference between the Imports(as % of merchandise exports) in Latin America(developing only) and Imports(as % of merchandise exports) in Cyprus?
Your response must be concise. 0.93. In the year 2000, what is the difference between the Imports(as % of merchandise exports) of Latin America(developing only) and Imports(as % of merchandise exports) of Slovenia?
Offer a very short reply. -2.83. In the year 2000, what is the difference between the Imports(as % of merchandise exports) in Latin America(developing only) and Imports(as % of merchandise exports) in United States?
Ensure brevity in your answer.  -0.08. In the year 2000, what is the difference between the Imports(as % of merchandise exports) in Cyprus and Imports(as % of merchandise exports) in Slovenia?
Provide a short and direct response. -3.76. In the year 2000, what is the difference between the Imports(as % of merchandise exports) in Cyprus and Imports(as % of merchandise exports) in United States?
Your answer should be very brief. -1.01. In the year 2000, what is the difference between the Imports(as % of merchandise exports) of Slovenia and Imports(as % of merchandise exports) of United States?
Provide a short and direct response. 2.75. What is the ratio of the Imports(as % of merchandise exports) of Latin America(developing only) in 1992 to that in 1993?
Offer a very short reply. 1.14. What is the ratio of the Imports(as % of merchandise exports) of Cyprus in 1992 to that in 1993?
Make the answer very short. 1.22. What is the ratio of the Imports(as % of merchandise exports) of Slovenia in 1992 to that in 1993?
Keep it short and to the point. 1.24. What is the ratio of the Imports(as % of merchandise exports) of United States in 1992 to that in 1993?
Keep it short and to the point. 1.08. What is the ratio of the Imports(as % of merchandise exports) in Latin America(developing only) in 1992 to that in 1995?
Ensure brevity in your answer.  1.01. What is the ratio of the Imports(as % of merchandise exports) of Cyprus in 1992 to that in 1995?
Your response must be concise. 1.36. What is the ratio of the Imports(as % of merchandise exports) of Slovenia in 1992 to that in 1995?
Your answer should be compact. 1.03. What is the ratio of the Imports(as % of merchandise exports) in United States in 1992 to that in 1995?
Provide a succinct answer. 0.89. What is the ratio of the Imports(as % of merchandise exports) in Latin America(developing only) in 1992 to that in 1996?
Keep it short and to the point. 1.08. What is the ratio of the Imports(as % of merchandise exports) in Cyprus in 1992 to that in 1996?
Give a very brief answer. 1.51. What is the ratio of the Imports(as % of merchandise exports) of Slovenia in 1992 to that in 1996?
Keep it short and to the point. 1.1. What is the ratio of the Imports(as % of merchandise exports) in United States in 1992 to that in 1996?
Provide a short and direct response. 0.99. What is the ratio of the Imports(as % of merchandise exports) of Latin America(developing only) in 1992 to that in 1997?
Your response must be concise. 1.03. What is the ratio of the Imports(as % of merchandise exports) of Cyprus in 1992 to that in 1997?
Provide a short and direct response. 1.6. What is the ratio of the Imports(as % of merchandise exports) of Slovenia in 1992 to that in 1997?
Offer a very short reply. 0.97. What is the ratio of the Imports(as % of merchandise exports) in United States in 1992 to that in 1997?
Your answer should be compact. 0.98. What is the ratio of the Imports(as % of merchandise exports) of Latin America(developing only) in 1992 to that in 1998?
Your answer should be very brief. 1.08. What is the ratio of the Imports(as % of merchandise exports) of Cyprus in 1992 to that in 1998?
Ensure brevity in your answer.  1.53. What is the ratio of the Imports(as % of merchandise exports) of Slovenia in 1992 to that in 1998?
Provide a succinct answer. 0.95. What is the ratio of the Imports(as % of merchandise exports) in Latin America(developing only) in 1992 to that in 1999?
Give a very brief answer. 1.11. What is the ratio of the Imports(as % of merchandise exports) in Cyprus in 1992 to that in 1999?
Your response must be concise. 1.54. What is the ratio of the Imports(as % of merchandise exports) of Slovenia in 1992 to that in 1999?
Your answer should be very brief. 0.98. What is the ratio of the Imports(as % of merchandise exports) in United States in 1992 to that in 1999?
Offer a terse response. 1.08. What is the ratio of the Imports(as % of merchandise exports) in Latin America(developing only) in 1992 to that in 2000?
Your answer should be very brief. 1.12. What is the ratio of the Imports(as % of merchandise exports) in Cyprus in 1992 to that in 2000?
Offer a very short reply. 1.47. What is the ratio of the Imports(as % of merchandise exports) in Slovenia in 1992 to that in 2000?
Your answer should be very brief. 0.84. What is the ratio of the Imports(as % of merchandise exports) in United States in 1992 to that in 2000?
Provide a succinct answer. 1.05. What is the ratio of the Imports(as % of merchandise exports) of Latin America(developing only) in 1993 to that in 1995?
Offer a terse response. 0.89. What is the ratio of the Imports(as % of merchandise exports) in Cyprus in 1993 to that in 1995?
Ensure brevity in your answer.  1.11. What is the ratio of the Imports(as % of merchandise exports) in Slovenia in 1993 to that in 1995?
Your answer should be compact. 0.83. What is the ratio of the Imports(as % of merchandise exports) in United States in 1993 to that in 1995?
Your answer should be compact. 0.82. What is the ratio of the Imports(as % of merchandise exports) of Latin America(developing only) in 1993 to that in 1996?
Give a very brief answer. 0.95. What is the ratio of the Imports(as % of merchandise exports) of Cyprus in 1993 to that in 1996?
Offer a terse response. 1.23. What is the ratio of the Imports(as % of merchandise exports) of Slovenia in 1993 to that in 1996?
Make the answer very short. 0.89. What is the ratio of the Imports(as % of merchandise exports) in United States in 1993 to that in 1996?
Ensure brevity in your answer.  0.92. What is the ratio of the Imports(as % of merchandise exports) in Latin America(developing only) in 1993 to that in 1997?
Provide a succinct answer. 0.91. What is the ratio of the Imports(as % of merchandise exports) in Cyprus in 1993 to that in 1997?
Offer a terse response. 1.31. What is the ratio of the Imports(as % of merchandise exports) of Slovenia in 1993 to that in 1997?
Provide a succinct answer. 0.78. What is the ratio of the Imports(as % of merchandise exports) of United States in 1993 to that in 1997?
Ensure brevity in your answer.  0.91. What is the ratio of the Imports(as % of merchandise exports) of Latin America(developing only) in 1993 to that in 1998?
Your answer should be compact. 0.95. What is the ratio of the Imports(as % of merchandise exports) of Cyprus in 1993 to that in 1998?
Your answer should be very brief. 1.26. What is the ratio of the Imports(as % of merchandise exports) in Slovenia in 1993 to that in 1998?
Provide a succinct answer. 0.77. What is the ratio of the Imports(as % of merchandise exports) in United States in 1993 to that in 1998?
Your answer should be very brief. 0.92. What is the ratio of the Imports(as % of merchandise exports) of Latin America(developing only) in 1993 to that in 1999?
Your answer should be very brief. 0.98. What is the ratio of the Imports(as % of merchandise exports) of Cyprus in 1993 to that in 1999?
Keep it short and to the point. 1.26. What is the ratio of the Imports(as % of merchandise exports) in Slovenia in 1993 to that in 1999?
Give a very brief answer. 0.79. What is the ratio of the Imports(as % of merchandise exports) in United States in 1993 to that in 1999?
Provide a short and direct response. 1. What is the ratio of the Imports(as % of merchandise exports) in Latin America(developing only) in 1993 to that in 2000?
Your answer should be compact. 0.99. What is the ratio of the Imports(as % of merchandise exports) of Cyprus in 1993 to that in 2000?
Offer a terse response. 1.2. What is the ratio of the Imports(as % of merchandise exports) of Slovenia in 1993 to that in 2000?
Your answer should be compact. 0.68. What is the ratio of the Imports(as % of merchandise exports) in Latin America(developing only) in 1995 to that in 1996?
Make the answer very short. 1.07. What is the ratio of the Imports(as % of merchandise exports) of Cyprus in 1995 to that in 1996?
Keep it short and to the point. 1.11. What is the ratio of the Imports(as % of merchandise exports) in Slovenia in 1995 to that in 1996?
Offer a very short reply. 1.07. What is the ratio of the Imports(as % of merchandise exports) in United States in 1995 to that in 1996?
Offer a very short reply. 1.11. What is the ratio of the Imports(as % of merchandise exports) of Latin America(developing only) in 1995 to that in 1997?
Provide a short and direct response. 1.02. What is the ratio of the Imports(as % of merchandise exports) in Cyprus in 1995 to that in 1997?
Offer a very short reply. 1.18. What is the ratio of the Imports(as % of merchandise exports) of Slovenia in 1995 to that in 1997?
Provide a succinct answer. 0.94. What is the ratio of the Imports(as % of merchandise exports) of United States in 1995 to that in 1997?
Provide a succinct answer. 1.11. What is the ratio of the Imports(as % of merchandise exports) of Latin America(developing only) in 1995 to that in 1998?
Your answer should be compact. 1.07. What is the ratio of the Imports(as % of merchandise exports) of Cyprus in 1995 to that in 1998?
Offer a terse response. 1.13. What is the ratio of the Imports(as % of merchandise exports) of Slovenia in 1995 to that in 1998?
Your answer should be very brief. 0.92. What is the ratio of the Imports(as % of merchandise exports) in United States in 1995 to that in 1998?
Ensure brevity in your answer.  1.11. What is the ratio of the Imports(as % of merchandise exports) in Latin America(developing only) in 1995 to that in 1999?
Your answer should be compact. 1.1. What is the ratio of the Imports(as % of merchandise exports) of Cyprus in 1995 to that in 1999?
Your answer should be compact. 1.13. What is the ratio of the Imports(as % of merchandise exports) in Slovenia in 1995 to that in 1999?
Give a very brief answer. 0.95. What is the ratio of the Imports(as % of merchandise exports) in United States in 1995 to that in 1999?
Keep it short and to the point. 1.21. What is the ratio of the Imports(as % of merchandise exports) in Latin America(developing only) in 1995 to that in 2000?
Offer a very short reply. 1.12. What is the ratio of the Imports(as % of merchandise exports) of Cyprus in 1995 to that in 2000?
Your response must be concise. 1.08. What is the ratio of the Imports(as % of merchandise exports) in Slovenia in 1995 to that in 2000?
Provide a short and direct response. 0.81. What is the ratio of the Imports(as % of merchandise exports) in United States in 1995 to that in 2000?
Your response must be concise. 1.19. What is the ratio of the Imports(as % of merchandise exports) in Latin America(developing only) in 1996 to that in 1997?
Provide a succinct answer. 0.95. What is the ratio of the Imports(as % of merchandise exports) of Cyprus in 1996 to that in 1997?
Ensure brevity in your answer.  1.06. What is the ratio of the Imports(as % of merchandise exports) in Slovenia in 1996 to that in 1997?
Offer a very short reply. 0.88. What is the ratio of the Imports(as % of merchandise exports) in Latin America(developing only) in 1996 to that in 1998?
Provide a short and direct response. 1. What is the ratio of the Imports(as % of merchandise exports) in Cyprus in 1996 to that in 1998?
Your answer should be compact. 1.02. What is the ratio of the Imports(as % of merchandise exports) in Slovenia in 1996 to that in 1998?
Provide a succinct answer. 0.86. What is the ratio of the Imports(as % of merchandise exports) in Latin America(developing only) in 1996 to that in 1999?
Make the answer very short. 1.03. What is the ratio of the Imports(as % of merchandise exports) of Cyprus in 1996 to that in 1999?
Offer a terse response. 1.02. What is the ratio of the Imports(as % of merchandise exports) of Slovenia in 1996 to that in 1999?
Ensure brevity in your answer.  0.88. What is the ratio of the Imports(as % of merchandise exports) in United States in 1996 to that in 1999?
Provide a succinct answer. 1.09. What is the ratio of the Imports(as % of merchandise exports) of Latin America(developing only) in 1996 to that in 2000?
Your response must be concise. 1.04. What is the ratio of the Imports(as % of merchandise exports) in Cyprus in 1996 to that in 2000?
Your response must be concise. 0.97. What is the ratio of the Imports(as % of merchandise exports) in Slovenia in 1996 to that in 2000?
Your answer should be very brief. 0.76. What is the ratio of the Imports(as % of merchandise exports) in United States in 1996 to that in 2000?
Your answer should be compact. 1.07. What is the ratio of the Imports(as % of merchandise exports) in Latin America(developing only) in 1997 to that in 1998?
Offer a terse response. 1.05. What is the ratio of the Imports(as % of merchandise exports) of Slovenia in 1997 to that in 1998?
Provide a short and direct response. 0.98. What is the ratio of the Imports(as % of merchandise exports) in Latin America(developing only) in 1997 to that in 1999?
Your answer should be very brief. 1.08. What is the ratio of the Imports(as % of merchandise exports) in Cyprus in 1997 to that in 1999?
Provide a short and direct response. 0.96. What is the ratio of the Imports(as % of merchandise exports) of Slovenia in 1997 to that in 1999?
Make the answer very short. 1.01. What is the ratio of the Imports(as % of merchandise exports) of United States in 1997 to that in 1999?
Your answer should be very brief. 1.09. What is the ratio of the Imports(as % of merchandise exports) in Latin America(developing only) in 1997 to that in 2000?
Provide a short and direct response. 1.09. What is the ratio of the Imports(as % of merchandise exports) of Cyprus in 1997 to that in 2000?
Keep it short and to the point. 0.92. What is the ratio of the Imports(as % of merchandise exports) of Slovenia in 1997 to that in 2000?
Ensure brevity in your answer.  0.86. What is the ratio of the Imports(as % of merchandise exports) in United States in 1997 to that in 2000?
Give a very brief answer. 1.07. What is the ratio of the Imports(as % of merchandise exports) in Latin America(developing only) in 1998 to that in 1999?
Your answer should be very brief. 1.03. What is the ratio of the Imports(as % of merchandise exports) of Slovenia in 1998 to that in 1999?
Your answer should be compact. 1.03. What is the ratio of the Imports(as % of merchandise exports) of United States in 1998 to that in 1999?
Make the answer very short. 1.09. What is the ratio of the Imports(as % of merchandise exports) in Latin America(developing only) in 1998 to that in 2000?
Keep it short and to the point. 1.04. What is the ratio of the Imports(as % of merchandise exports) of Cyprus in 1998 to that in 2000?
Ensure brevity in your answer.  0.96. What is the ratio of the Imports(as % of merchandise exports) of Slovenia in 1998 to that in 2000?
Provide a short and direct response. 0.88. What is the ratio of the Imports(as % of merchandise exports) of United States in 1998 to that in 2000?
Your response must be concise. 1.06. What is the ratio of the Imports(as % of merchandise exports) in Latin America(developing only) in 1999 to that in 2000?
Give a very brief answer. 1.01. What is the ratio of the Imports(as % of merchandise exports) in Cyprus in 1999 to that in 2000?
Provide a short and direct response. 0.95. What is the ratio of the Imports(as % of merchandise exports) in Slovenia in 1999 to that in 2000?
Provide a succinct answer. 0.86. What is the ratio of the Imports(as % of merchandise exports) in United States in 1999 to that in 2000?
Make the answer very short. 0.98. What is the difference between the highest and the second highest Imports(as % of merchandise exports) of Latin America(developing only)?
Your answer should be very brief. 0.02. What is the difference between the highest and the second highest Imports(as % of merchandise exports) in Cyprus?
Ensure brevity in your answer.  0.31. What is the difference between the highest and the second highest Imports(as % of merchandise exports) in Slovenia?
Ensure brevity in your answer.  0.58. What is the difference between the highest and the second highest Imports(as % of merchandise exports) of United States?
Your response must be concise. 0.25. What is the difference between the highest and the lowest Imports(as % of merchandise exports) in Latin America(developing only)?
Your answer should be compact. 0.28. What is the difference between the highest and the lowest Imports(as % of merchandise exports) in Cyprus?
Provide a succinct answer. 0.64. What is the difference between the highest and the lowest Imports(as % of merchandise exports) in Slovenia?
Your response must be concise. 1.6. What is the difference between the highest and the lowest Imports(as % of merchandise exports) of United States?
Give a very brief answer. 0.45. 